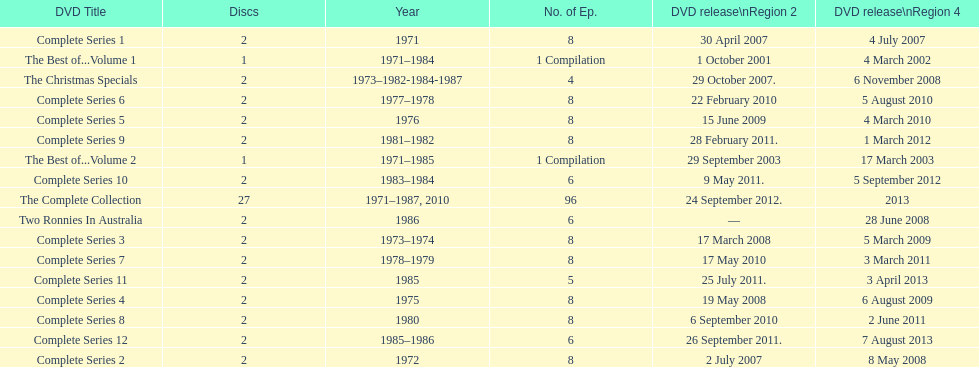What is previous to complete series 10? Complete Series 9. 